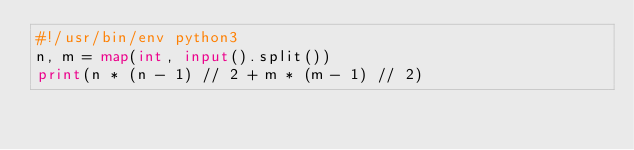Convert code to text. <code><loc_0><loc_0><loc_500><loc_500><_Python_>#!/usr/bin/env python3
n, m = map(int, input().split())
print(n * (n - 1) // 2 + m * (m - 1) // 2)
</code> 